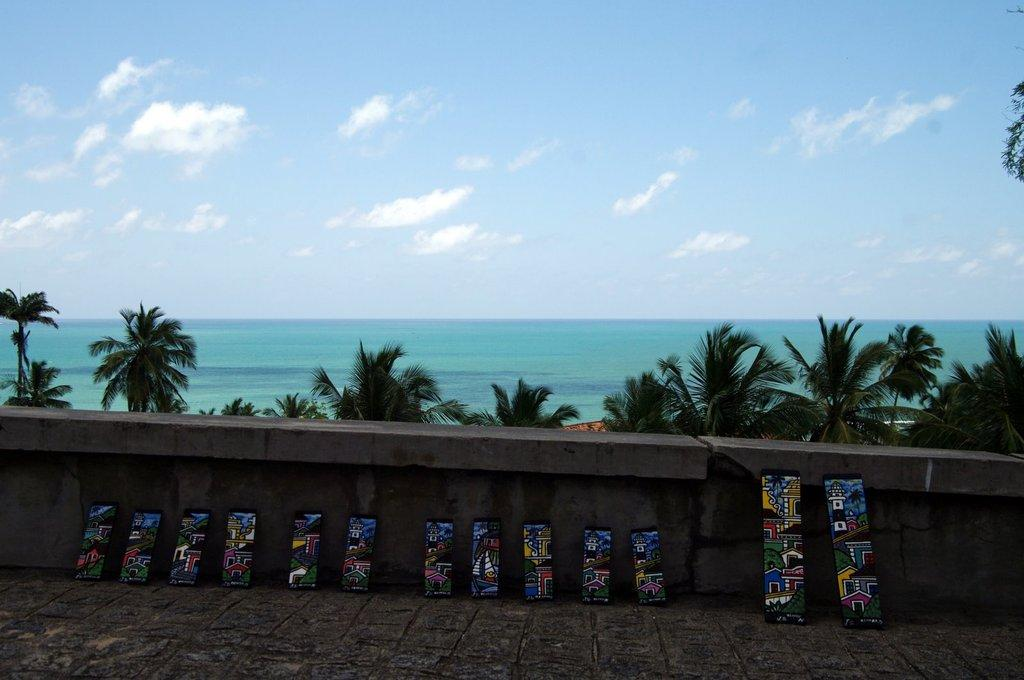What is placed on the wall-side in the image? There are skating pads laid to the wall. What can be seen behind the wall? There are trees behind the wall. What is visible in the background beyond the trees? There is a sea visible in the background. What type of trousers are being worn by the trees in the image? There are no trousers visible in the image, as the trees are not wearing any clothing. 